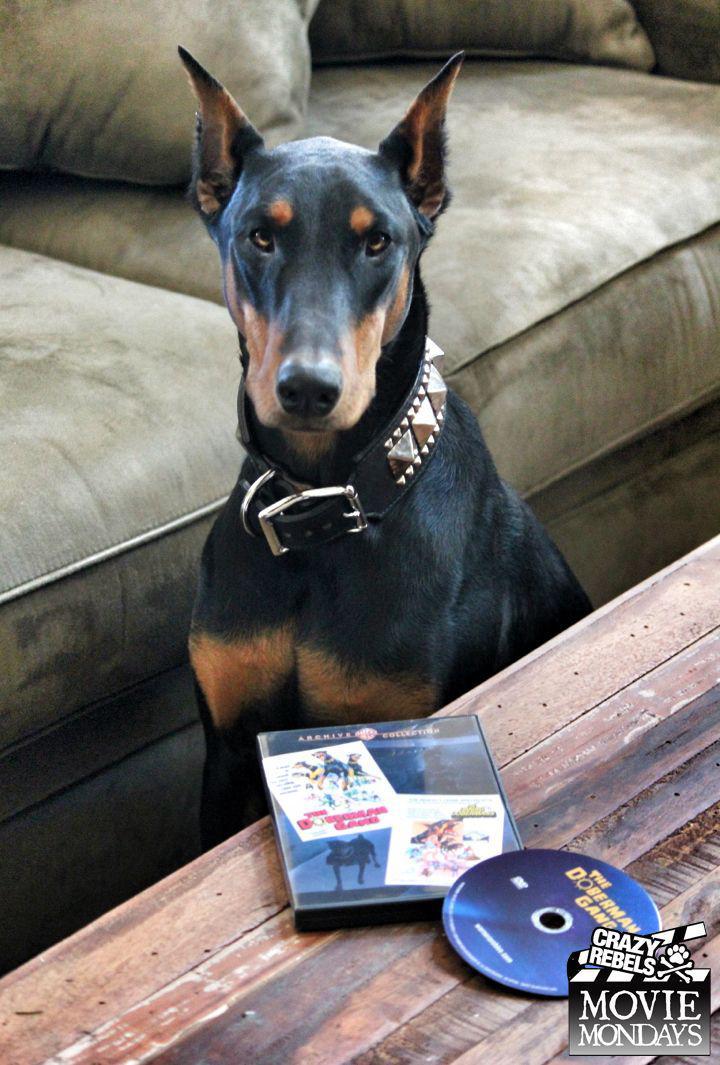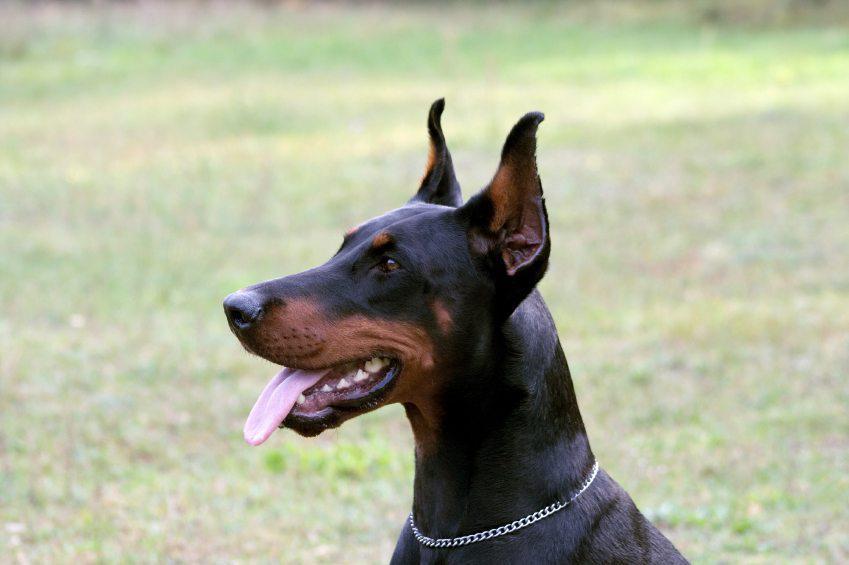The first image is the image on the left, the second image is the image on the right. For the images shown, is this caption "There are at least five dogs." true? Answer yes or no. No. The first image is the image on the left, the second image is the image on the right. Examine the images to the left and right. Is the description "There are more dogs in the image on the right" accurate? Answer yes or no. No. 